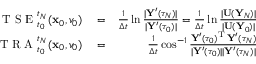<formula> <loc_0><loc_0><loc_500><loc_500>\begin{array} { r l r } { T S E _ { t _ { 0 } } ^ { t _ { N } } ( { \mathbf x } _ { 0 } , v _ { 0 } ) } & = } & { \frac { 1 } { \Delta t } \ln \frac { | { \mathbf Y } ^ { \prime } ( \tau _ { N } ) | } { | { \mathbf Y } ^ { \prime } ( \tau _ { 0 } ) | } = \frac { 1 } { \Delta t } \ln \frac { | { \mathbf U } ( { \mathbf Y } _ { N } ) | } { | { \mathbf U } ( { \mathbf Y } _ { 0 } ) | } } \\ { T R A _ { t _ { 0 } } ^ { t _ { N } } ( { \mathbf x } _ { 0 } , v _ { 0 } ) } & = } & { \frac { 1 } { \Delta t } \cos ^ { - 1 } \frac { { \mathbf Y } ^ { \prime } ( \tau _ { 0 } ) ^ { \mathrm T } \, { \mathbf Y } ^ { \prime } ( \tau _ { N } ) } { | { \mathbf Y } ^ { \prime } ( \tau _ { 0 } ) | | { \mathbf Y } ^ { \prime } ( \tau _ { N } ) | } } \end{array}</formula> 